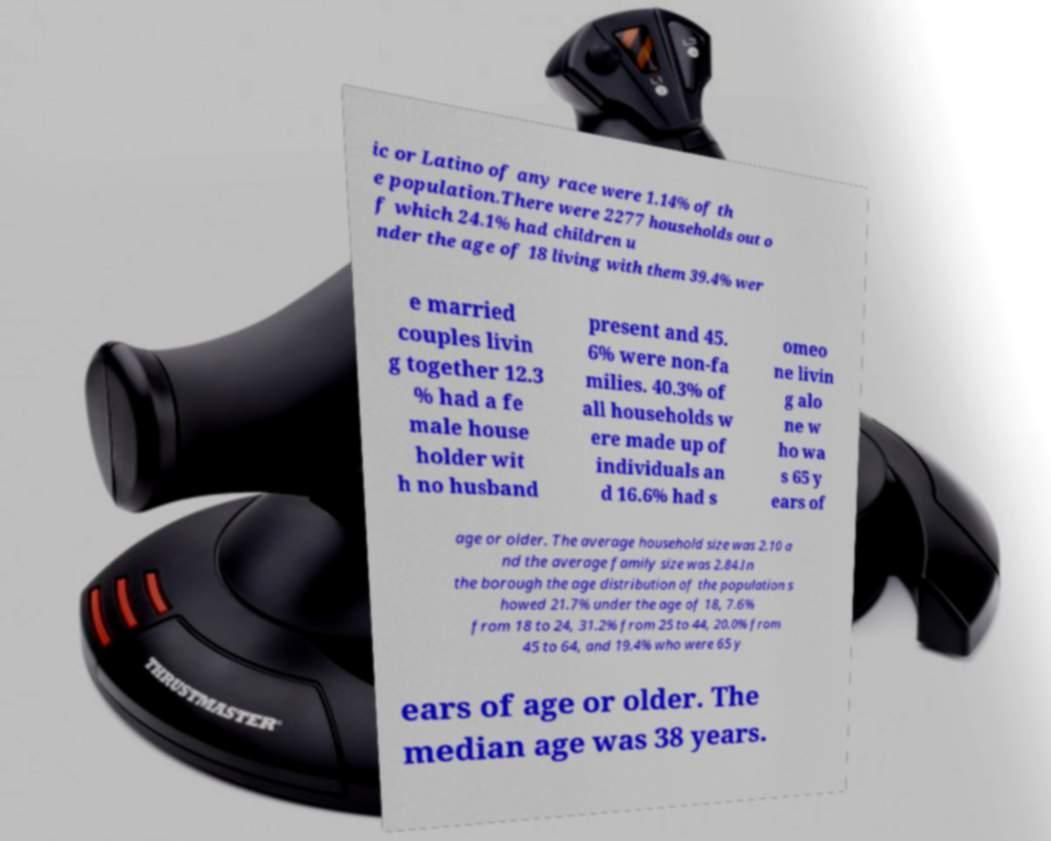Can you read and provide the text displayed in the image?This photo seems to have some interesting text. Can you extract and type it out for me? ic or Latino of any race were 1.14% of th e population.There were 2277 households out o f which 24.1% had children u nder the age of 18 living with them 39.4% wer e married couples livin g together 12.3 % had a fe male house holder wit h no husband present and 45. 6% were non-fa milies. 40.3% of all households w ere made up of individuals an d 16.6% had s omeo ne livin g alo ne w ho wa s 65 y ears of age or older. The average household size was 2.10 a nd the average family size was 2.84.In the borough the age distribution of the population s howed 21.7% under the age of 18, 7.6% from 18 to 24, 31.2% from 25 to 44, 20.0% from 45 to 64, and 19.4% who were 65 y ears of age or older. The median age was 38 years. 